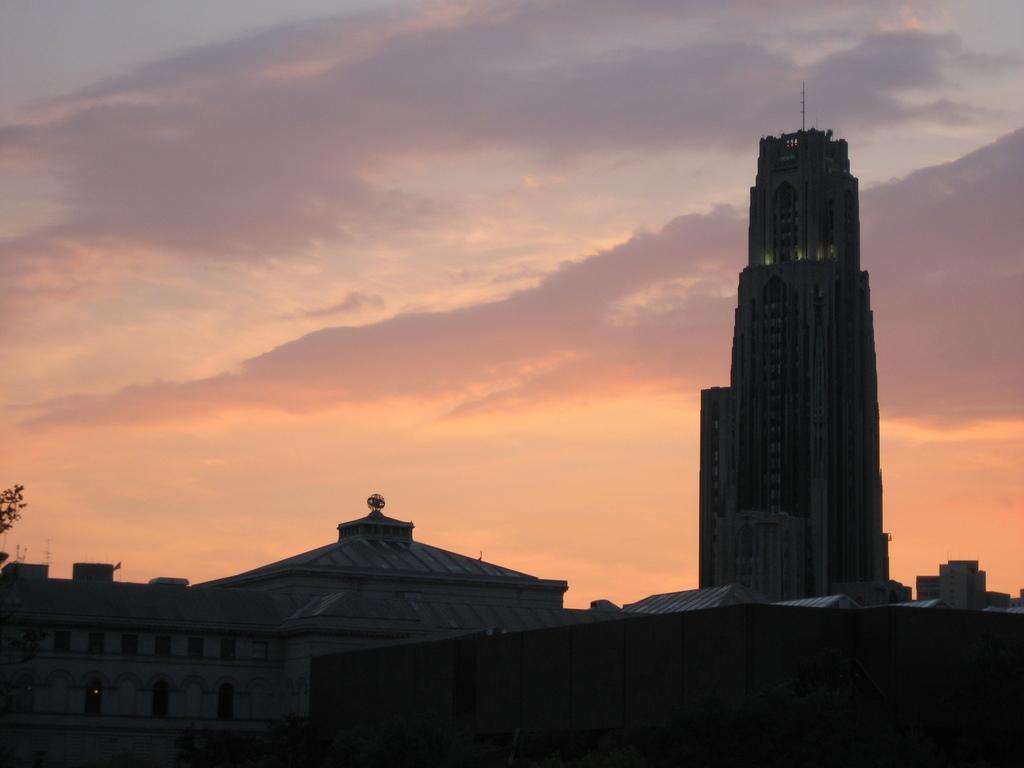Can you describe this image briefly? In this image, there are a few houses. We can see some leaves on the left. We can also see the sky with clouds. 